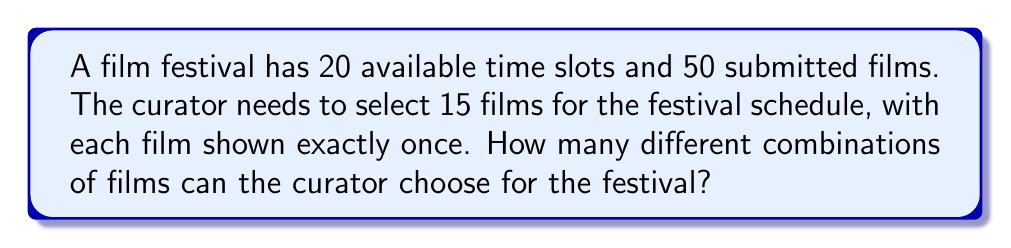Teach me how to tackle this problem. Let's approach this step-by-step:

1) This is a combination problem. We are selecting 15 films out of 50, where the order doesn't matter (as we're just choosing which films to include, not scheduling them yet).

2) The formula for combinations is:

   $$C(n,r) = \frac{n!}{r!(n-r)!}$$

   Where $n$ is the total number of items to choose from, and $r$ is the number of items being chosen.

3) In this case, $n = 50$ (total films) and $r = 15$ (films to be selected).

4) Plugging these values into our formula:

   $$C(50,15) = \frac{50!}{15!(50-15)!} = \frac{50!}{15!35!}$$

5) Calculating this:
   
   $$\frac{50!}{15!35!} = 2,250,829,575,560,806,400$$

6) Note: The number of time slots (20) doesn't affect the number of combinations of films that can be chosen. It only indicates that there are more time slots than films being shown, which is feasible for the schedule.
Answer: 2,250,829,575,560,806,400 